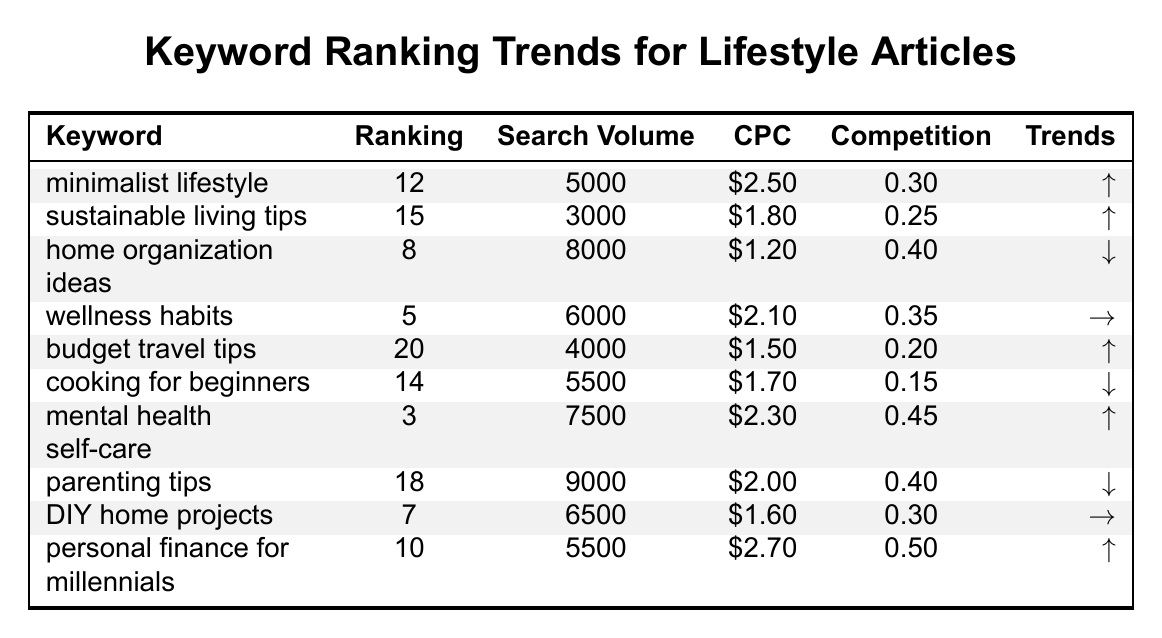What's the keyword with the highest ranking? The table shows the rank for each keyword, and "mental health self-care" has the highest ranking at 3.
Answer: mental health self-care Which keyword has the lowest search volume? By checking the "Search Volume" column, "sustainable living tips" has the lowest search volume at 3000.
Answer: sustainable living tips How many keywords have a ranking above 15? Three keywords have a ranking above 15: "budget travel tips" (20), "parenting tips" (18), and "sustainable living tips" (15).
Answer: 3 What is the average CPC of all keywords listed? We sum the CPC values: (2.50 + 1.80 + 1.20 + 2.10 + 1.50 + 1.70 + 2.30 + 2.00 + 1.60 + 2.70) = 19.70 and divide by 10 (the number of keywords), resulting in an average CPC of 1.97.
Answer: 1.97 Which keyword has the highest competition value? Looking at the "Competition" column, "personal finance for millennials" has the highest value at 0.50.
Answer: personal finance for millennials How many keywords showed a decrease in trending? From the "Trends" column, three keywords are marked with a downward trend: "home organization ideas," "cooking for beginners," and "parenting tips."
Answer: 3 What's the difference in search volume between the keyword "mental health self-care" and "sustainable living tips"? The search volume for "mental health self-care" is 7500 and for "sustainable living tips" is 3000. The difference is 7500 - 3000 = 4500.
Answer: 4500 Is there any keyword that has the same ranking as any other keyword? Yes, "minimalist lifestyle" and "personal finance for millennials" both have different ranking values.
Answer: No Which keywords have a trending up arrow? The keywords with an upward trend are "minimalist lifestyle," "sustainable living tips," "mental health self-care," "personal finance for millennials," and "budget travel tips."
Answer: 5 What is the median ranking among the listed keywords? The rankings sorted from lowest to highest are: 3, 5, 7, 8, 10, 12, 14, 15, 18, 20. The median ranking is the average of the 5th and 6th values: (10 + 12) / 2 = 11.
Answer: 11 How many keywords are ranked in positions 1 to 5? There are 4 keywords ranked in positions 1 to 5: "mental health self-care" (3), "wellness habits" (5), "DIY home projects" (7), and "home organization ideas" (8).
Answer: 4 